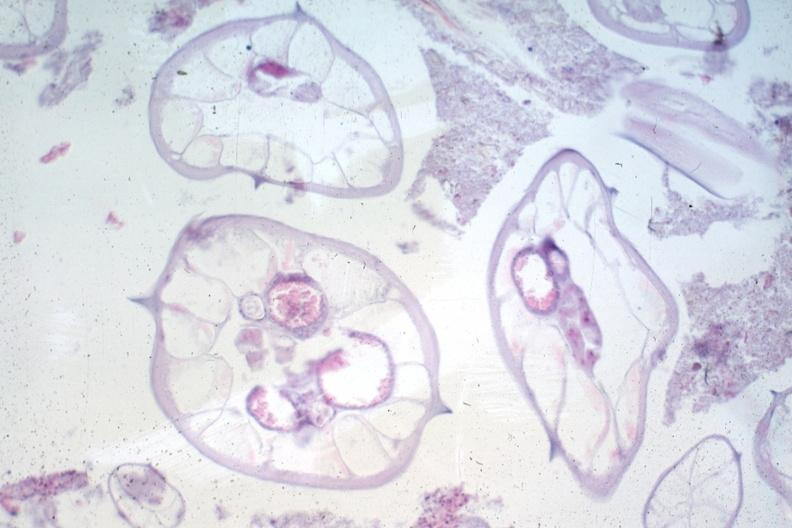s gastrointestinal present?
Answer the question using a single word or phrase. Yes 